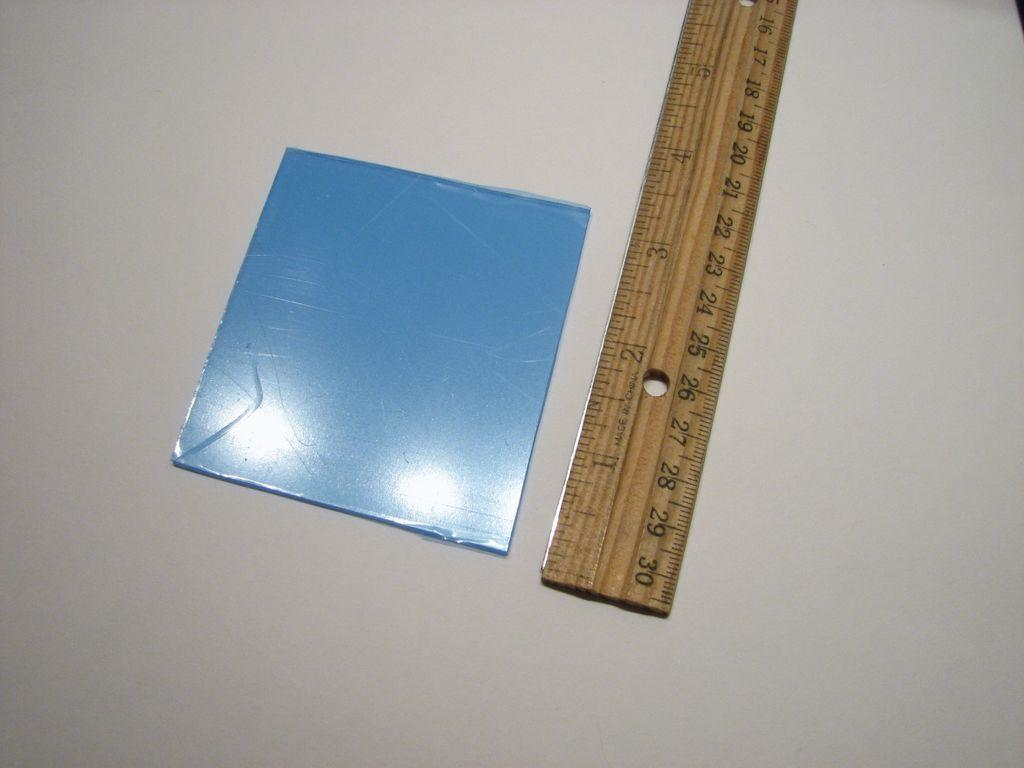<image>
Share a concise interpretation of the image provided. a ruler that goes all the way up to 30 centimeters 